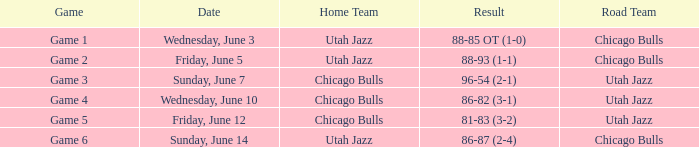Result of 88-85 ot (1-0) involves what game? Game 1. Can you give me this table as a dict? {'header': ['Game', 'Date', 'Home Team', 'Result', 'Road Team'], 'rows': [['Game 1', 'Wednesday, June 3', 'Utah Jazz', '88-85 OT (1-0)', 'Chicago Bulls'], ['Game 2', 'Friday, June 5', 'Utah Jazz', '88-93 (1-1)', 'Chicago Bulls'], ['Game 3', 'Sunday, June 7', 'Chicago Bulls', '96-54 (2-1)', 'Utah Jazz'], ['Game 4', 'Wednesday, June 10', 'Chicago Bulls', '86-82 (3-1)', 'Utah Jazz'], ['Game 5', 'Friday, June 12', 'Chicago Bulls', '81-83 (3-2)', 'Utah Jazz'], ['Game 6', 'Sunday, June 14', 'Utah Jazz', '86-87 (2-4)', 'Chicago Bulls']]} 